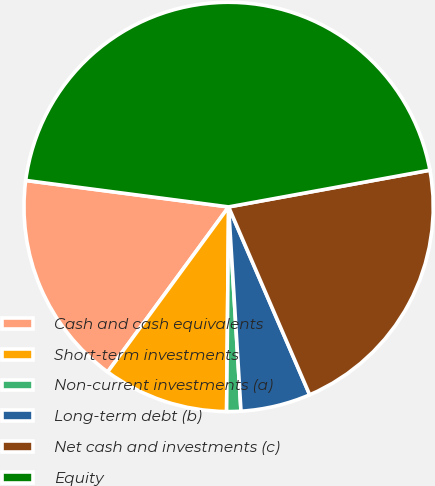Convert chart to OTSL. <chart><loc_0><loc_0><loc_500><loc_500><pie_chart><fcel>Cash and cash equivalents<fcel>Short-term investments<fcel>Non-current investments (a)<fcel>Long-term debt (b)<fcel>Net cash and investments (c)<fcel>Equity<nl><fcel>17.0%<fcel>9.91%<fcel>1.12%<fcel>5.52%<fcel>21.39%<fcel>45.06%<nl></chart> 